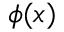Convert formula to latex. <formula><loc_0><loc_0><loc_500><loc_500>\phi ( { x } )</formula> 